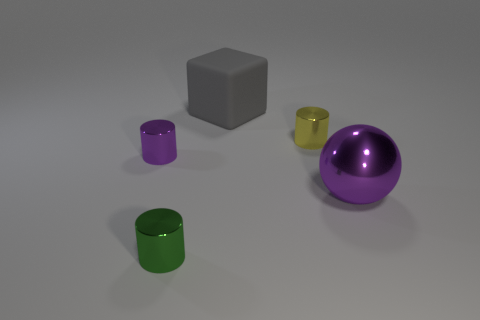What number of small green things are in front of the small thing on the left side of the cylinder in front of the ball? There is one small green cylinder positioned in front of the smaller grey cube on the left side of the purple cylinder that is itself in front of the purple ball. 